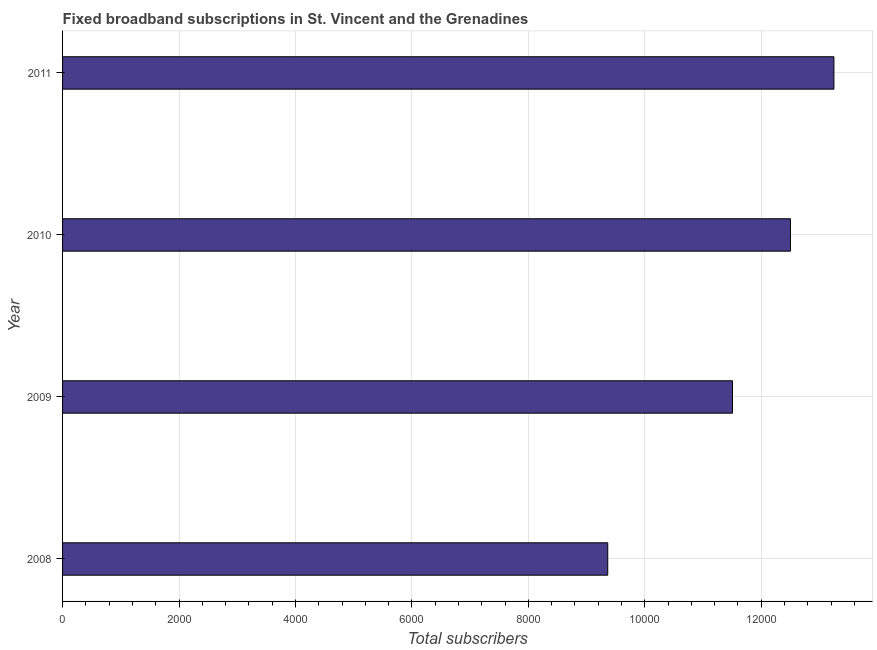Does the graph contain any zero values?
Make the answer very short. No. What is the title of the graph?
Keep it short and to the point. Fixed broadband subscriptions in St. Vincent and the Grenadines. What is the label or title of the X-axis?
Ensure brevity in your answer.  Total subscribers. What is the label or title of the Y-axis?
Give a very brief answer. Year. What is the total number of fixed broadband subscriptions in 2009?
Give a very brief answer. 1.15e+04. Across all years, what is the maximum total number of fixed broadband subscriptions?
Your response must be concise. 1.32e+04. Across all years, what is the minimum total number of fixed broadband subscriptions?
Make the answer very short. 9364. In which year was the total number of fixed broadband subscriptions minimum?
Ensure brevity in your answer.  2008. What is the sum of the total number of fixed broadband subscriptions?
Give a very brief answer. 4.66e+04. What is the difference between the total number of fixed broadband subscriptions in 2008 and 2011?
Your answer should be compact. -3885. What is the average total number of fixed broadband subscriptions per year?
Keep it short and to the point. 1.17e+04. What is the median total number of fixed broadband subscriptions?
Your answer should be compact. 1.20e+04. In how many years, is the total number of fixed broadband subscriptions greater than 9600 ?
Keep it short and to the point. 3. What is the ratio of the total number of fixed broadband subscriptions in 2008 to that in 2010?
Offer a terse response. 0.75. Is the difference between the total number of fixed broadband subscriptions in 2008 and 2010 greater than the difference between any two years?
Make the answer very short. No. What is the difference between the highest and the second highest total number of fixed broadband subscriptions?
Provide a succinct answer. 747. Is the sum of the total number of fixed broadband subscriptions in 2008 and 2010 greater than the maximum total number of fixed broadband subscriptions across all years?
Your response must be concise. Yes. What is the difference between the highest and the lowest total number of fixed broadband subscriptions?
Offer a very short reply. 3885. How many bars are there?
Your answer should be very brief. 4. Are all the bars in the graph horizontal?
Ensure brevity in your answer.  Yes. What is the difference between two consecutive major ticks on the X-axis?
Ensure brevity in your answer.  2000. Are the values on the major ticks of X-axis written in scientific E-notation?
Your answer should be compact. No. What is the Total subscribers in 2008?
Your answer should be compact. 9364. What is the Total subscribers in 2009?
Provide a succinct answer. 1.15e+04. What is the Total subscribers in 2010?
Provide a succinct answer. 1.25e+04. What is the Total subscribers in 2011?
Give a very brief answer. 1.32e+04. What is the difference between the Total subscribers in 2008 and 2009?
Offer a terse response. -2143. What is the difference between the Total subscribers in 2008 and 2010?
Keep it short and to the point. -3138. What is the difference between the Total subscribers in 2008 and 2011?
Keep it short and to the point. -3885. What is the difference between the Total subscribers in 2009 and 2010?
Provide a short and direct response. -995. What is the difference between the Total subscribers in 2009 and 2011?
Your answer should be very brief. -1742. What is the difference between the Total subscribers in 2010 and 2011?
Offer a terse response. -747. What is the ratio of the Total subscribers in 2008 to that in 2009?
Offer a terse response. 0.81. What is the ratio of the Total subscribers in 2008 to that in 2010?
Offer a terse response. 0.75. What is the ratio of the Total subscribers in 2008 to that in 2011?
Make the answer very short. 0.71. What is the ratio of the Total subscribers in 2009 to that in 2011?
Offer a terse response. 0.87. What is the ratio of the Total subscribers in 2010 to that in 2011?
Offer a terse response. 0.94. 